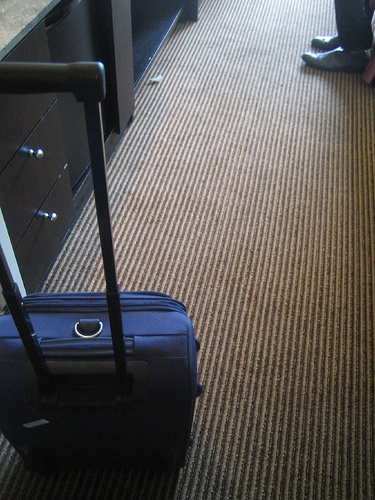Describe the objects in this image and their specific colors. I can see suitcase in gray, black, navy, and blue tones and people in gray, black, and darkblue tones in this image. 